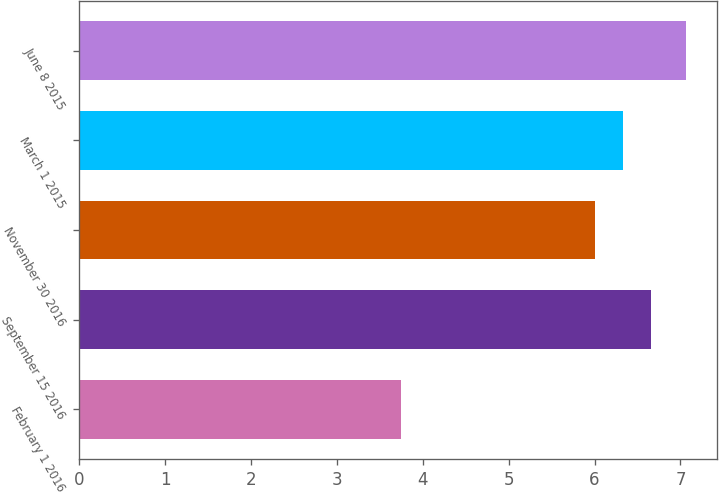Convert chart to OTSL. <chart><loc_0><loc_0><loc_500><loc_500><bar_chart><fcel>February 1 2016<fcel>September 15 2016<fcel>November 30 2016<fcel>March 1 2015<fcel>June 8 2015<nl><fcel>3.75<fcel>6.66<fcel>6<fcel>6.33<fcel>7.07<nl></chart> 